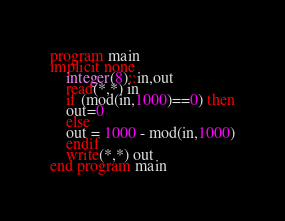<code> <loc_0><loc_0><loc_500><loc_500><_FORTRAN_>program main
implicit none
	integer(8)::in,out
    read(*,*) in
    if (mod(in,1000)==0) then
    out=0
    else 
    out = 1000 - mod(in,1000)
    endif
    write(*,*) out
end program main</code> 